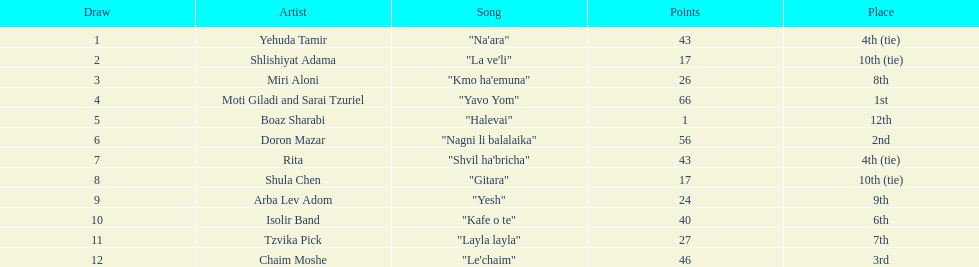What is the total number of points that the artist rita possesses? 43. 